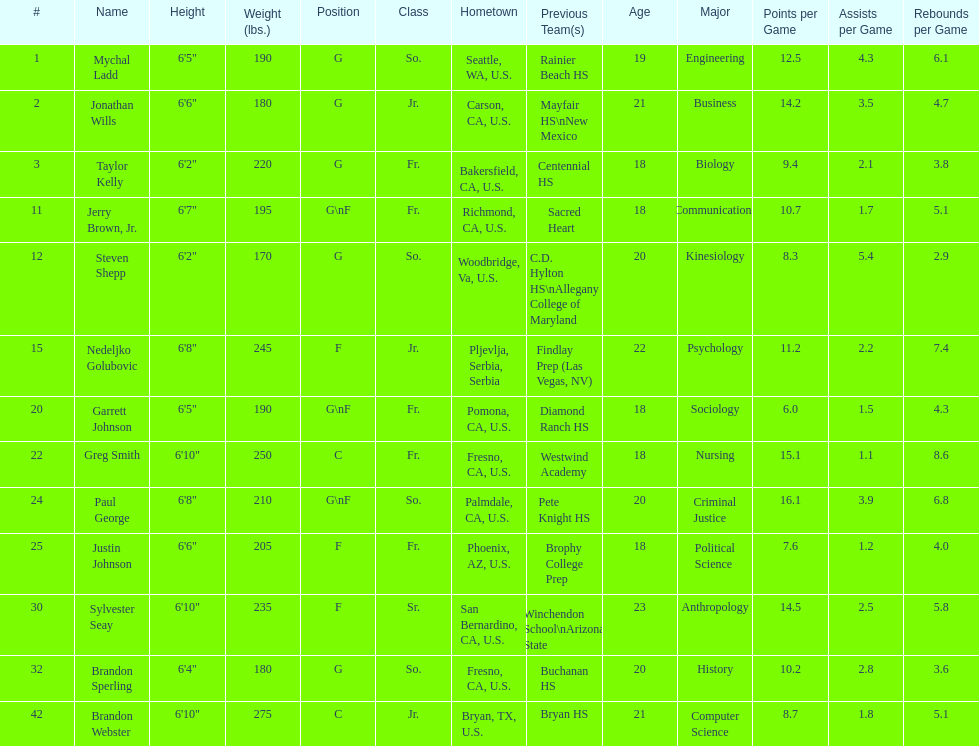How many players hometowns are outside of california? 5. 